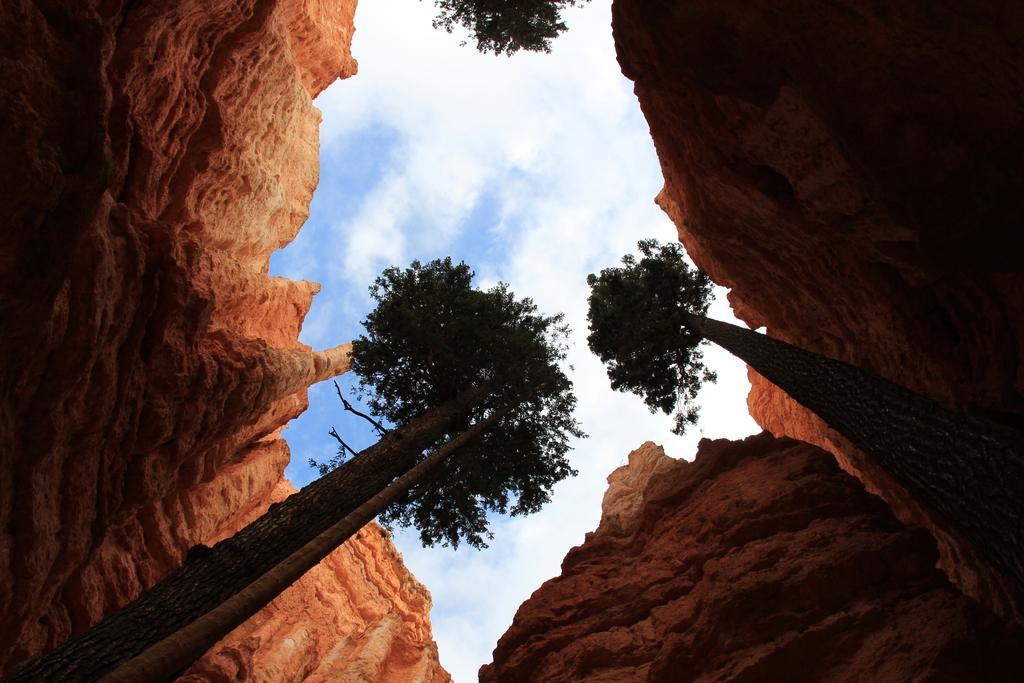Could you give a brief overview of what you see in this image? In this image I can see few trees which are brown and green in color and few huge rocky mountains around the trees which are brown and orange in color and in the background I can see the sky. 